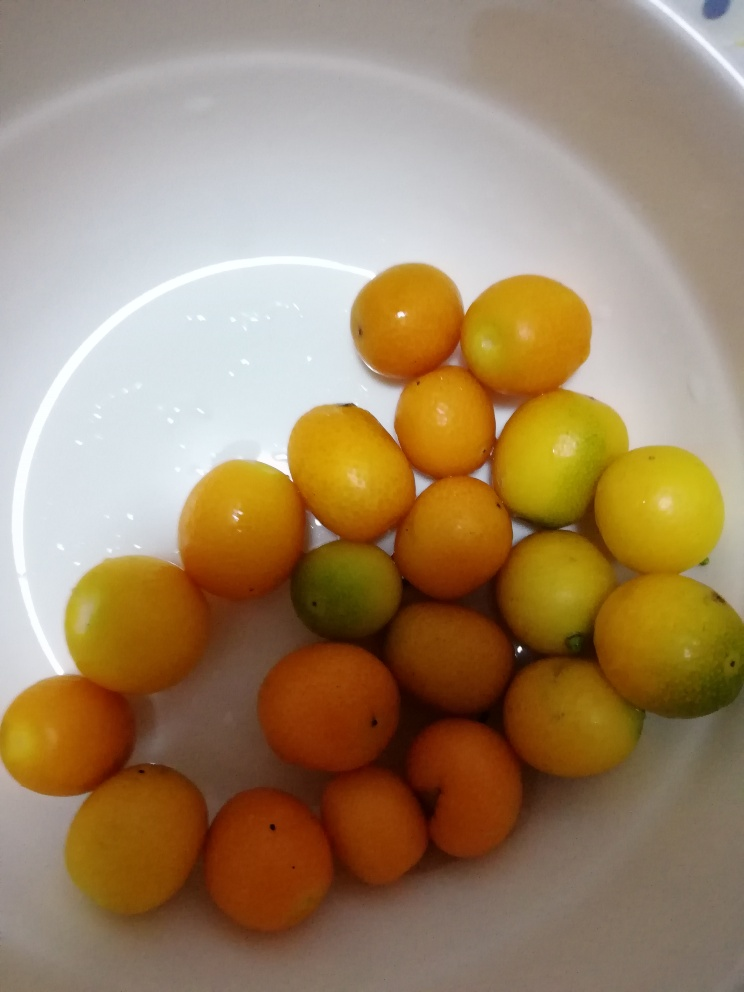How are the colors in this image? The image features a vibrant and warm array of colors dominated by shades of yellow and orange with hints of green, showcasing what appears to be a collection of fresh, ripe citrus fruits resting in a clean white bowl. The color variation among the fruits suggests different degrees of ripeness or possibly different types of citrus. 